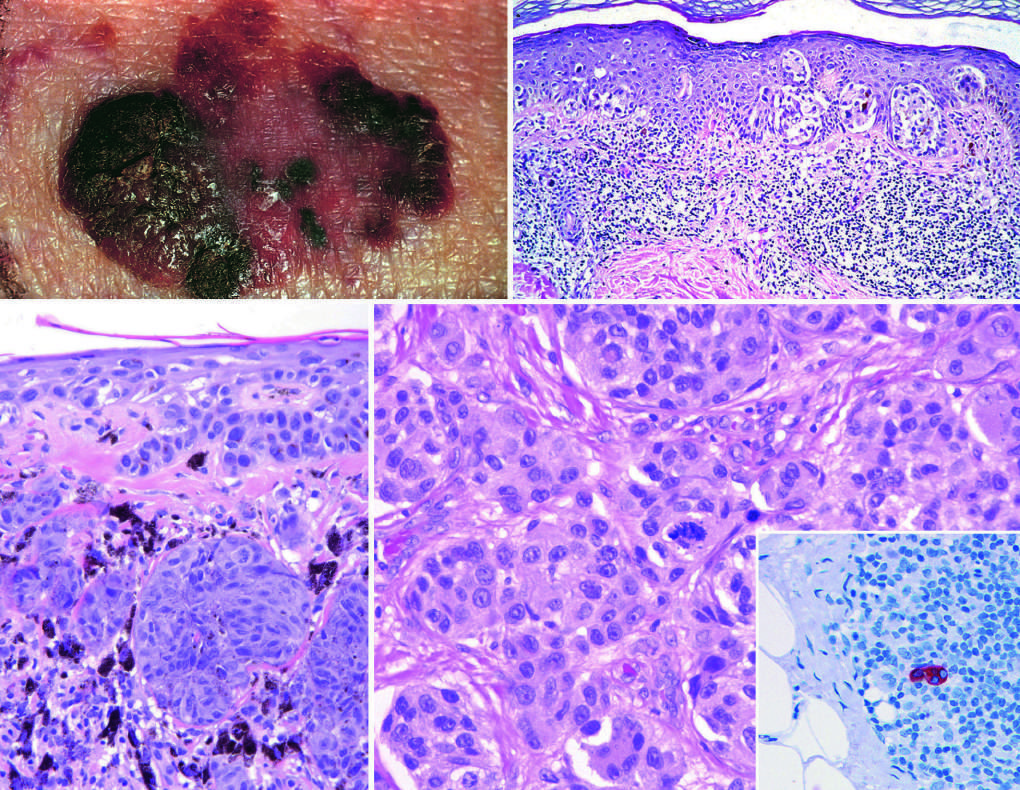do elevated areas indicate dermal invasion vertical growth?
Answer the question using a single word or phrase. Yes 